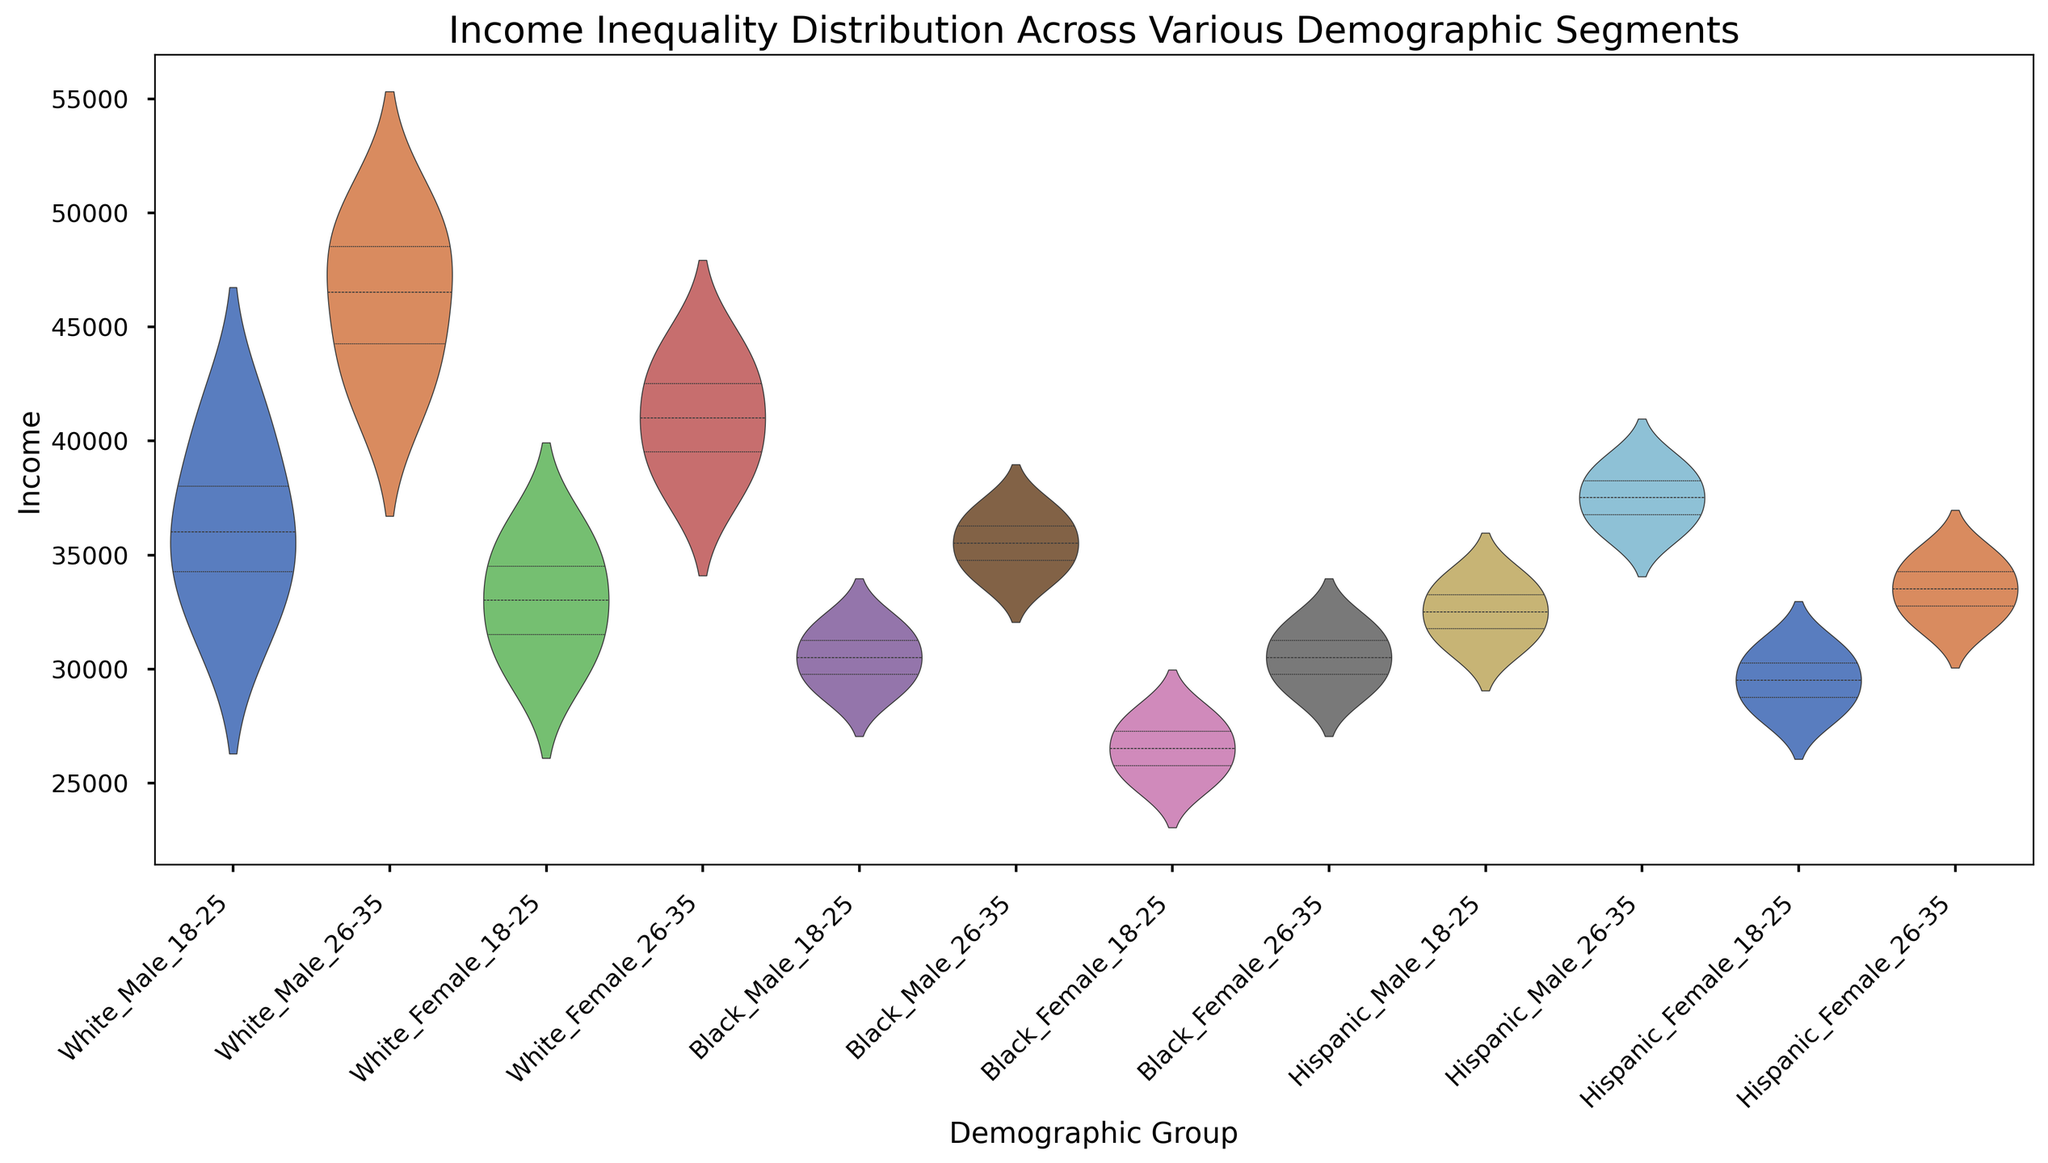What is the income range for Hispanic Female aged 26-35? To find the income range, observe the minimum and maximum points of the distribution for Hispanic Female aged 26-35 on the x-axis. The range is from 32,000 to 35,000.
Answer: 32,000 to 35,000 Which demographic group has the widest income distribution? The width of the violin plot represents the spread of income. By looking at the plot, White Male aged 26-35 shows the widest distribution.
Answer: White Male 26-35 What is the median income for Black Female aged 18-25? The white dot inside the violin plot indicates the median value. For Black Female aged 18-25, the median is at approximately 27,000.
Answer: 27,000 Compare the median incomes of White Male 18-25 and Black Male 26-35. Which is higher? Look at the white dots inside the violin plots of both demographics. White Male 18-25 has a median income at around 36,000, while Black Male 26-35 has a median around 35,000.
Answer: White Male 18-25 What is the income interquartile range (IQR) for White Female aged 26-35? To find the IQR, look at the range between the first and third quartiles (the thickest part of the violin). For White Female aged 26-35, this range is between 38,000 and 42,000, so the IQR is 42,000 - 38,000 = 4,000.
Answer: 4,000 Which demographic has the lowest median income? The white dot indicates the median value for each plot. Black Female aged 18-25 shows the lowest median income, which is around 27,000.
Answer: Black Female 18-25 Compare the average incomes of White Female aged 18-25 and Hispanic Male aged 26-35. Visual cues in the violin plot indicate average values near the center's thickest part. White Female 18-25 has an average around 32,500, while Hispanic Male 26-35 has an average around 37,000.
Answer: Hispanic Male 26-35 Which demographic shows the least income inequality? The violin plot with the shortest height and narrowest width indicates the least variability. Black Female aged 26-35 shows the least income inequality.
Answer: Black Female 26-35 